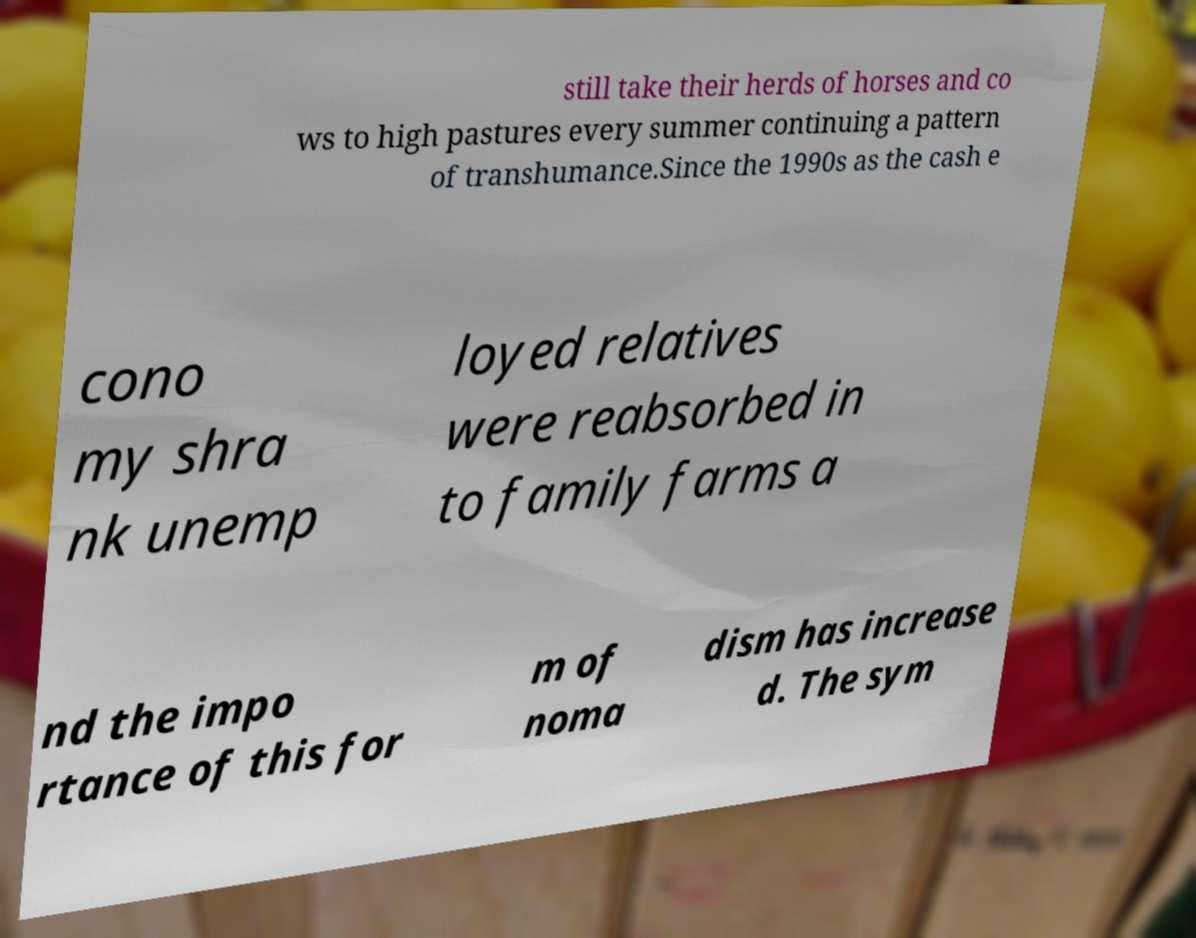What messages or text are displayed in this image? I need them in a readable, typed format. still take their herds of horses and co ws to high pastures every summer continuing a pattern of transhumance.Since the 1990s as the cash e cono my shra nk unemp loyed relatives were reabsorbed in to family farms a nd the impo rtance of this for m of noma dism has increase d. The sym 